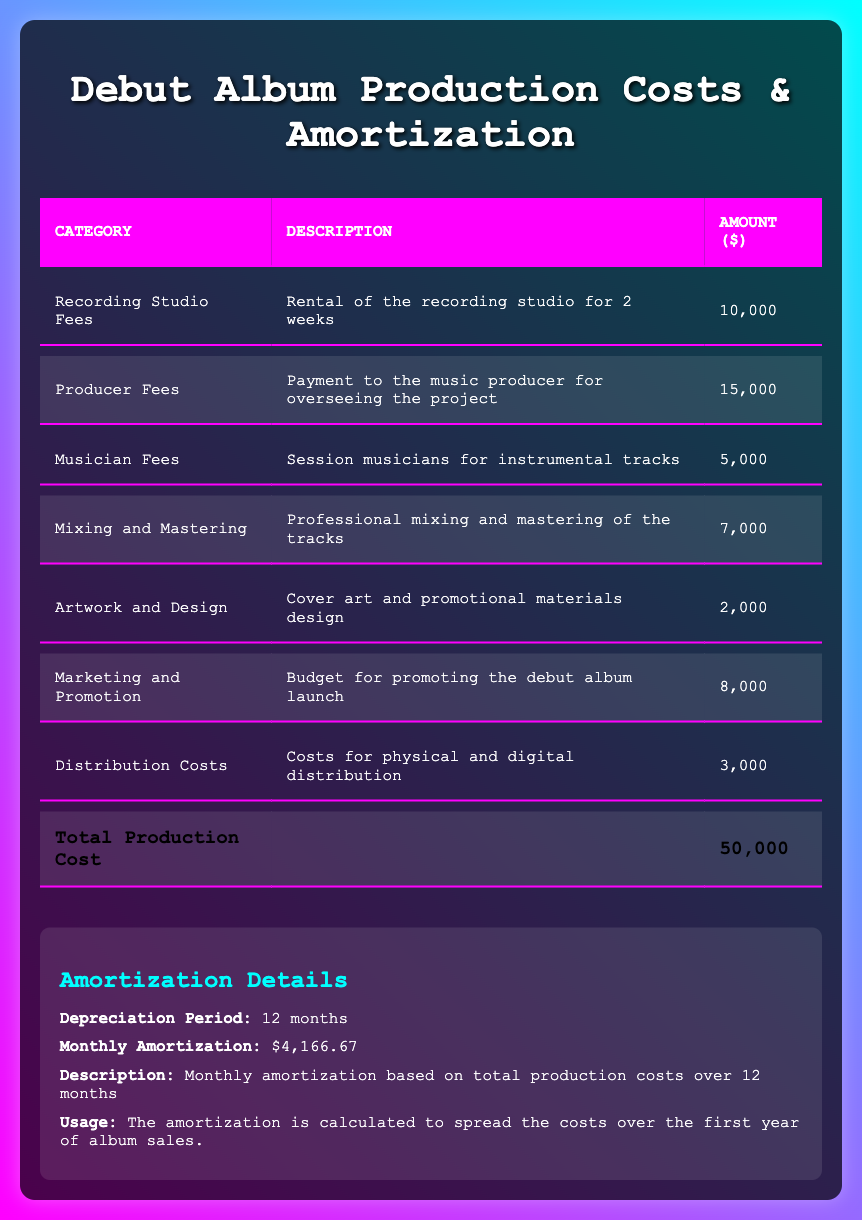What is the total production cost of the debut album? The total production cost is listed at the bottom of the table under the total row, which shows an amount of 50,000 dollars.
Answer: 50,000 How much was spent on producer fees? The producer fees are indicated in the second row of the table, where it shows an amount of 15,000 dollars.
Answer: 15,000 Is the amount for marketing and promotion more than the artwork and design costs? The marketing and promotion amount is 8,000 dollars, while artwork and design costs are 2,000 dollars. Since 8,000 is greater than 2,000, the statement is true.
Answer: Yes What is the total amount spent on recording studio fees and musician fees combined? The recording studio fees are 10,000 dollars, and the musician fees are 5,000 dollars. Adding these amounts gives us 10,000 + 5,000 = 15,000 dollars.
Answer: 15,000 If the album's production costs are amortized over 12 months, what is the monthly amortization amount? The monthly amortization amount is provided directly in the amortization details section. It states that the monthly amortization is 4,166.67 dollars.
Answer: 4,166.67 Does the total amount for mixing and mastering exceed the costs for distribution? Mixing and mastering costs are listed as 7,000 dollars, while distribution costs are 3,000 dollars. Since 7,000 is more than 3,000, the answer is yes.
Answer: Yes What is the difference between the producer fees and the mixing and mastering costs? The producer fees are 15,000 dollars, and the mixing and mastering costs are 7,000 dollars. The difference is calculated by subtracting: 15,000 - 7,000 = 8,000 dollars.
Answer: 8,000 What percentage of the total production cost is allocated to artwork and design? The artwork and design costs are 2,000 dollars, and to find the percentage, we calculate (2,000 / 50,000) * 100 = 4 percent.
Answer: 4 percent What expenses have amounts greater than or equal to 8,000 dollars? Looking at the table, the expenses that meet this condition are the producer fees (15,000) and marketing and promotion (8,000). Both are listed, confirming the answer.
Answer: Producer Fees, Marketing and Promotion 